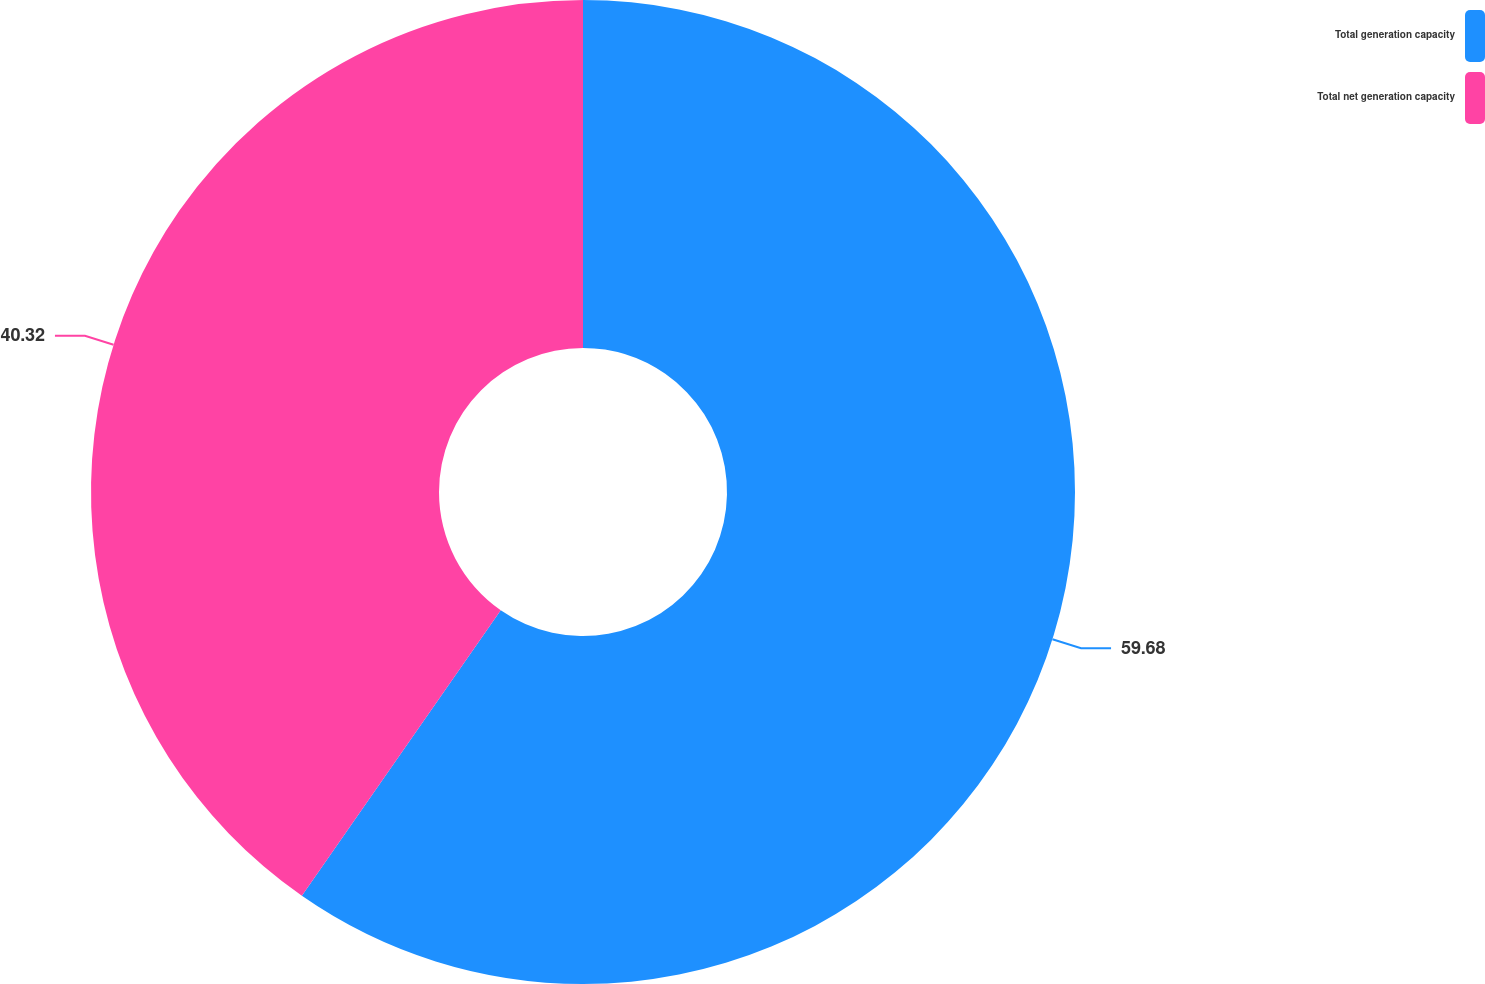Convert chart to OTSL. <chart><loc_0><loc_0><loc_500><loc_500><pie_chart><fcel>Total generation capacity<fcel>Total net generation capacity<nl><fcel>59.68%<fcel>40.32%<nl></chart> 